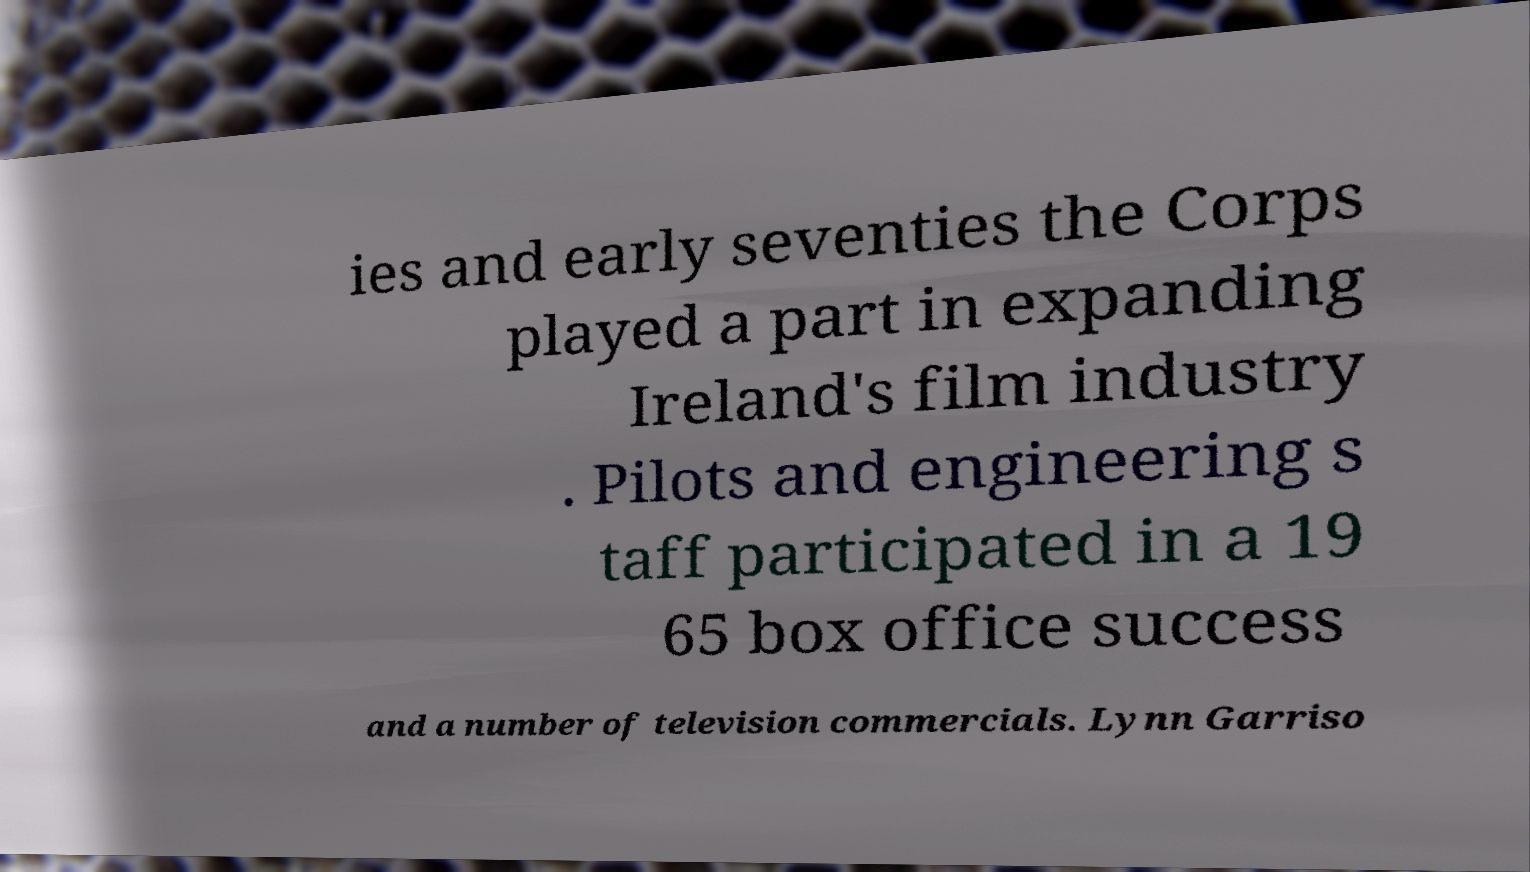Please identify and transcribe the text found in this image. ies and early seventies the Corps played a part in expanding Ireland's film industry . Pilots and engineering s taff participated in a 19 65 box office success and a number of television commercials. Lynn Garriso 